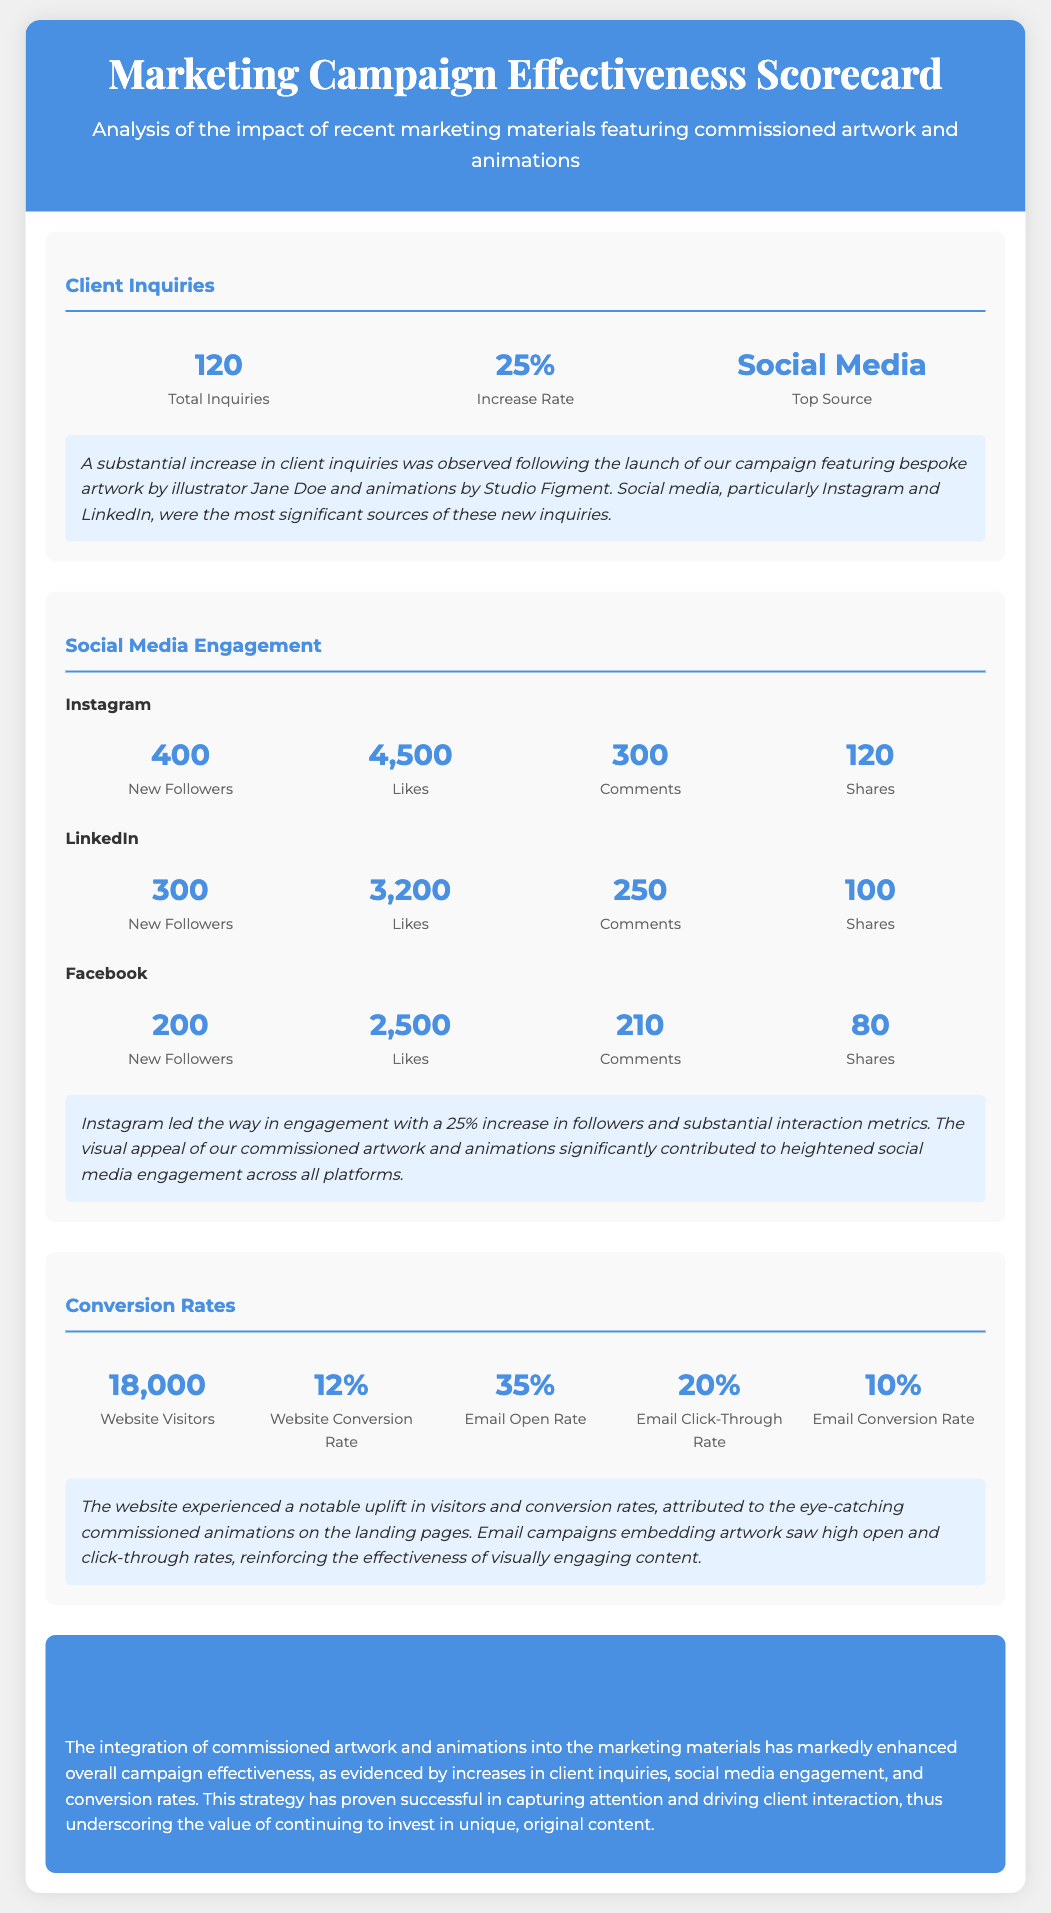what was the total number of client inquiries? The total number of client inquiries is stated in the Client Inquiries section as 120.
Answer: 120 what percentage increase in client inquiries was observed? The increase rate of client inquiries is provided in the document as 25%.
Answer: 25% which social media platform was the top source of inquiries? The document indicates that Social Media, specifically Instagram and LinkedIn, were the top sources of inquiries.
Answer: Social Media how many new followers did Instagram gain? The document shows that Instagram had 400 new followers.
Answer: 400 what was the website conversion rate according to the scorecard? The website conversion rate is listed in the Conversion Rates section as 12%.
Answer: 12% how many total website visitors were recorded? The document mentions that there were 18,000 website visitors.
Answer: 18,000 what was the email click-through rate? The email click-through rate is stated as 20% in the Conversion Rates section.
Answer: 20% which platform saw the highest number of likes? The platform with the highest likes is Instagram with 4,500 likes.
Answer: Instagram what was the insight regarding social media engagement? The insight indicates that Instagram led in engagement with a 25% increase in followers.
Answer: Instagram led in engagement with a 25% increase in followers 